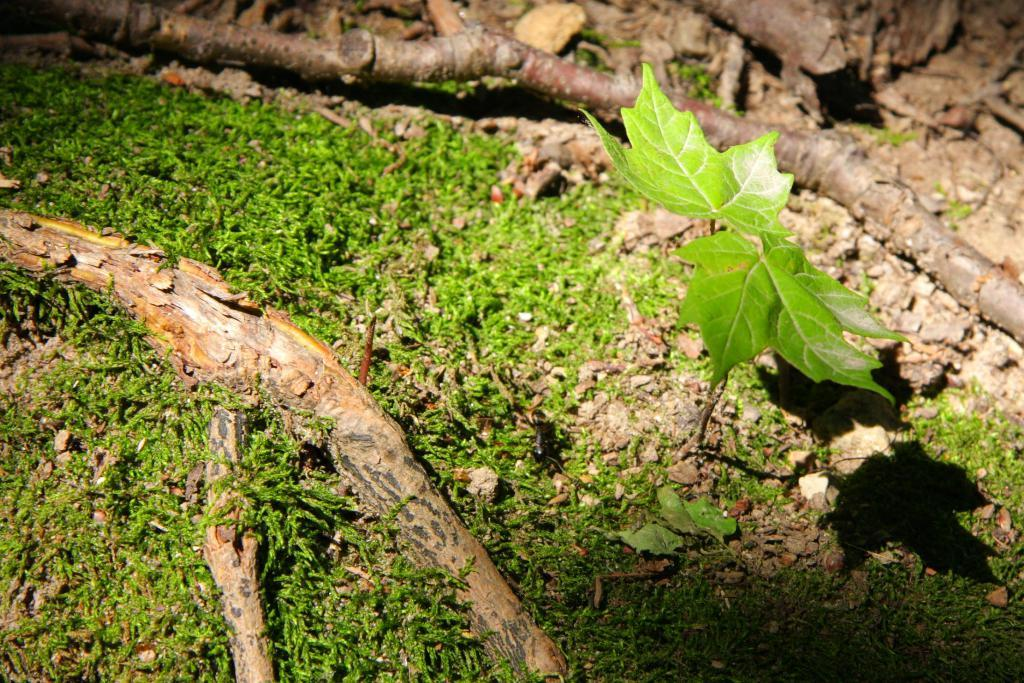What type of surface is visible in the image? There is ground visible in the image. What type of vegetation is present on the ground? There is grass on the ground. What type of plant can be seen in the image? There is a plant in the image. What material are the objects made of that are visible in the image? There are wooden objects in the image. How many cows are grazing on the grass in the image? There are no cows present in the image. What type of bikes are being ridden by the people in the image? There are no bikes or people present in the image. 